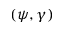<formula> <loc_0><loc_0><loc_500><loc_500>( \psi , \gamma )</formula> 